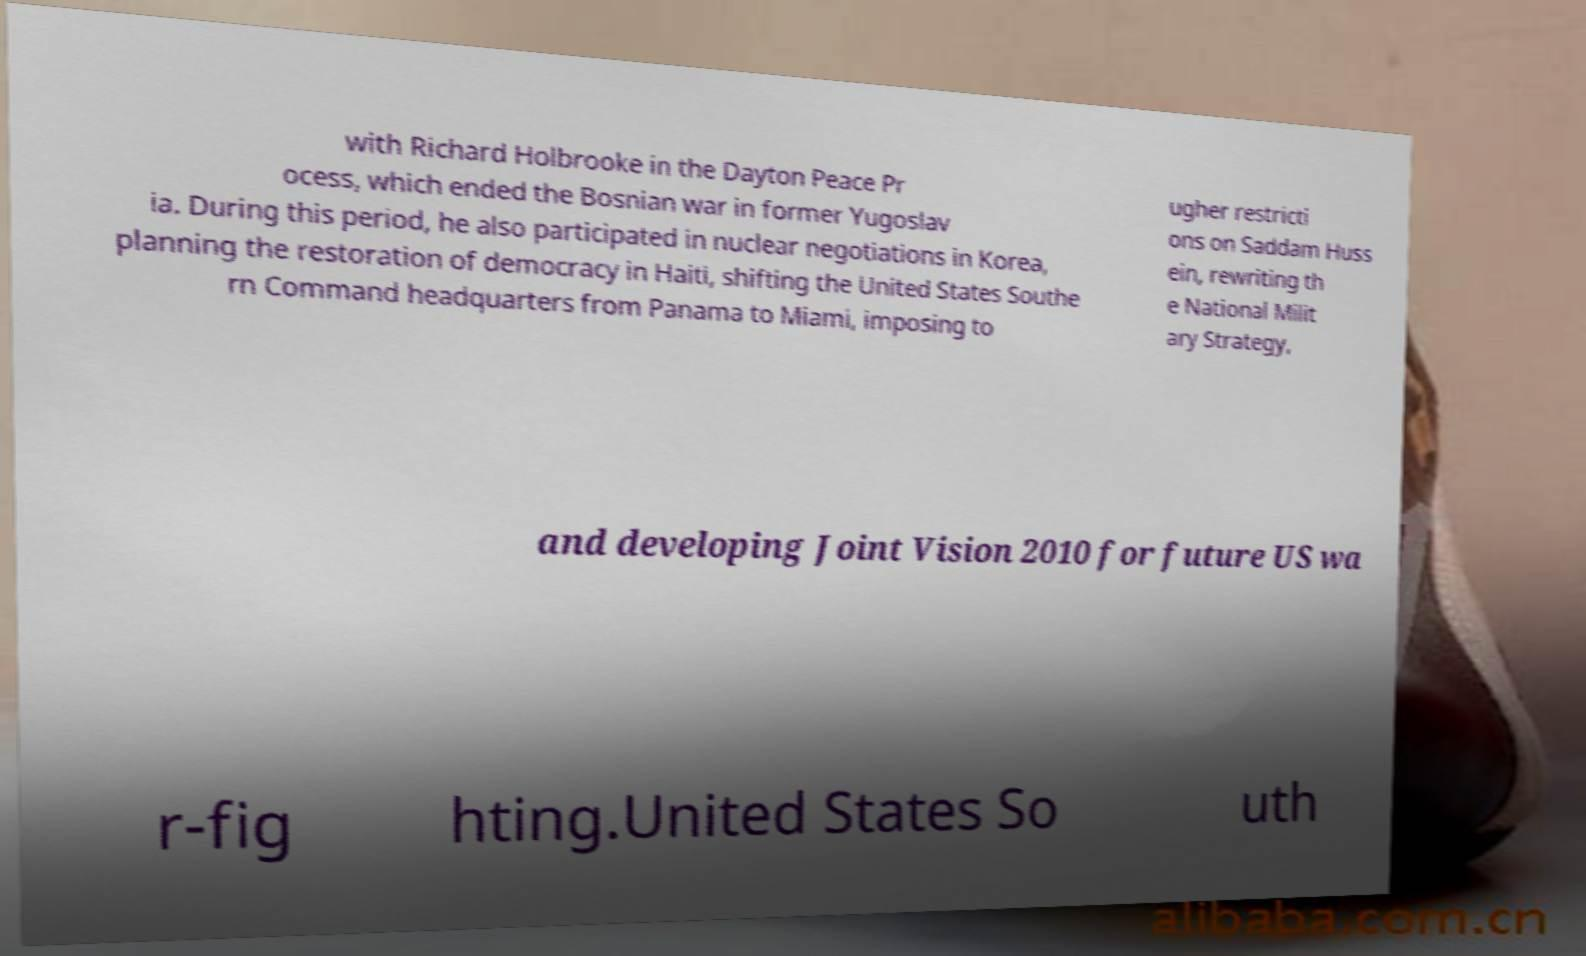For documentation purposes, I need the text within this image transcribed. Could you provide that? with Richard Holbrooke in the Dayton Peace Pr ocess, which ended the Bosnian war in former Yugoslav ia. During this period, he also participated in nuclear negotiations in Korea, planning the restoration of democracy in Haiti, shifting the United States Southe rn Command headquarters from Panama to Miami, imposing to ugher restricti ons on Saddam Huss ein, rewriting th e National Milit ary Strategy, and developing Joint Vision 2010 for future US wa r-fig hting.United States So uth 